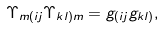<formula> <loc_0><loc_0><loc_500><loc_500>\Upsilon _ { m ( i j } \Upsilon _ { k l ) m } = g _ { ( i j } g _ { k l ) } ,</formula> 